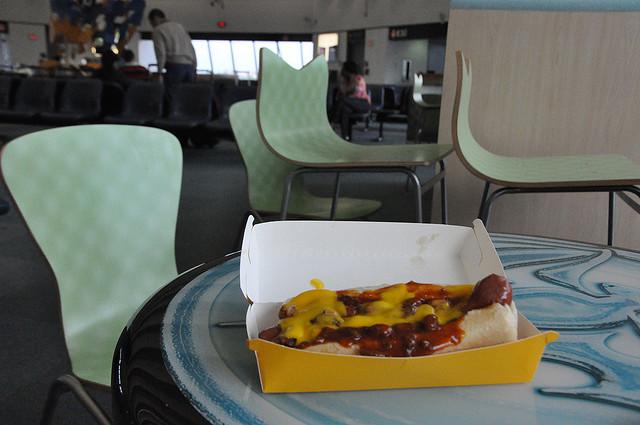Where are the napkins?
Give a very brief answer. Kitchen. What color is the box?
Be succinct. Yellow. What food dish is this?
Give a very brief answer. Hot dog. 